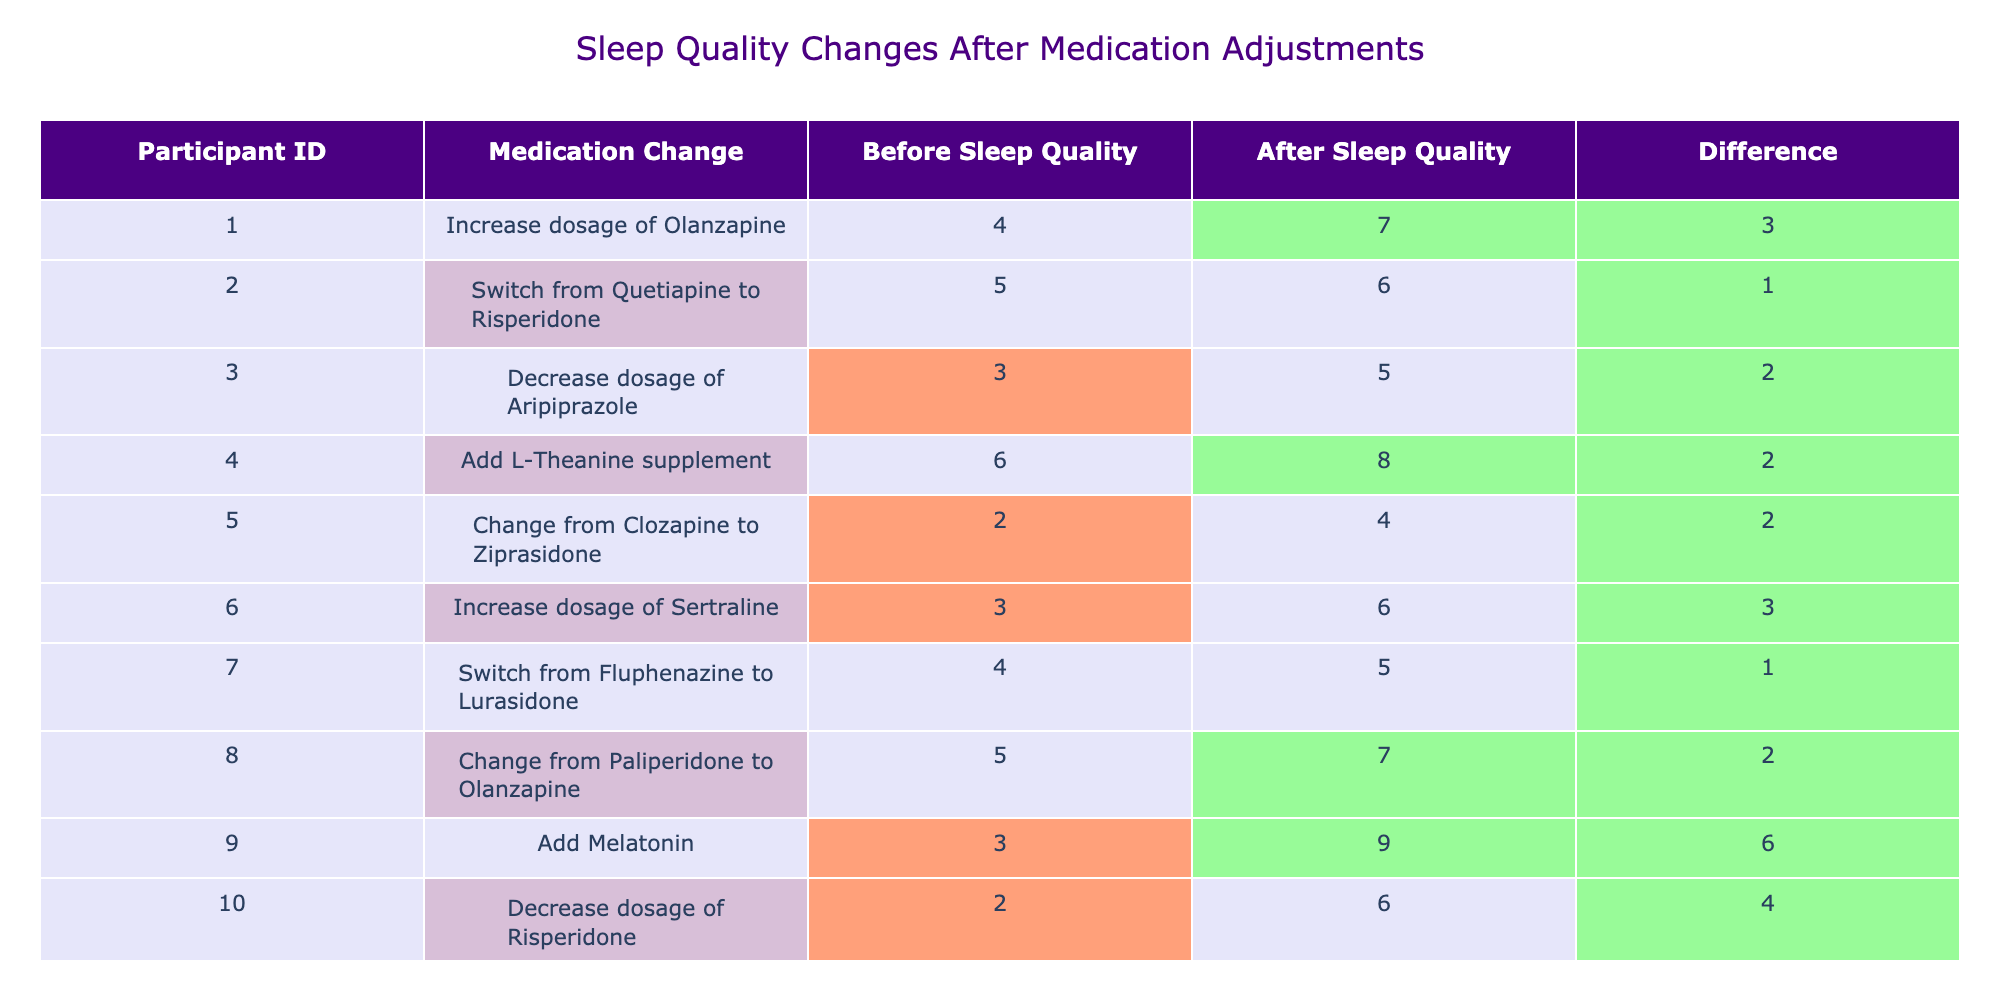What is the highest "Before Sleep Quality Rating"? Looking at the "Before Sleep Quality Rating" column, the values are 4, 5, 3, 6, 2, 3, 4, 5, 3, and 2. The highest value among these is 6.
Answer: 6 Which participant had the greatest improvement in sleep quality? The "Sleep Quality Difference" column shows the differences: 3, 1, 2, 2, 2, 3, 1, 2, 6, and 4. The greatest improvement is 6, which belongs to participant 9.
Answer: Participant 9 What was the "Before Sleep Quality Rating" for participants who switched medications? The participants who switched medications are 2, 5, 7, and 8, with ratings of 5, 2, 4, and 5, respectively. These ratings are collected: 5, 2, 4, 5.
Answer: 5, 2, 4, 5 What is the average "After Sleep Quality Rating"? The "After Sleep Quality Rating" values are 7, 6, 5, 8, 4, 6, 5, 7, 9, and 6. Summing these gives 63, and dividing by 10 (the number of participants), the average is 6.3.
Answer: 6.3 Did any participant experience a decrease in sleep quality? By inspecting the "Sleep Quality Difference" column, all values are positive or zero, meaning no participant's sleep quality decreased.
Answer: No How many participants had a "Before Sleep Quality Rating" of 3 or less? Checking the "Before Sleep Quality Rating" column, participants with ratings of 3 or less are 3 (3), 5 (2), and 10 (2). That's three participants.
Answer: 3 How many participants improved their sleep quality by more than 2 points? The "Sleep Quality Difference" values show improvements of 3, 1, 2, 2, 2, 3, 1, 2, 6, and 4. The values greater than 2 are 3 and 6, corresponding to 4 participants.
Answer: 4 What is the median "After Sleep Quality Rating"? The "After Sleep Quality Rating" values sorted are 4, 5, 5, 5, 6, 6, 7, 7, 8, and 9. The median is the average of the 5th and 6th values (6, 6), resulting in 6.
Answer: 6 Which medication change resulted in the lowest quality rating after the change? The "After Sleep Quality Rating" values are 7, 6, 5, 8, 4, 6, 5, 7, 9, and 6. The lowest rating is 4, associated with the change from Clozapine to Ziprasidone.
Answer: Clozapine to Ziprasidone What is the total improvement in sleep quality across all participants? Summing up the "Sleep Quality Difference" values (3 + 1 + 2 + 2 + 2 + 3 + 1 + 2 + 6 + 4) results in a total improvement of 26.
Answer: 26 